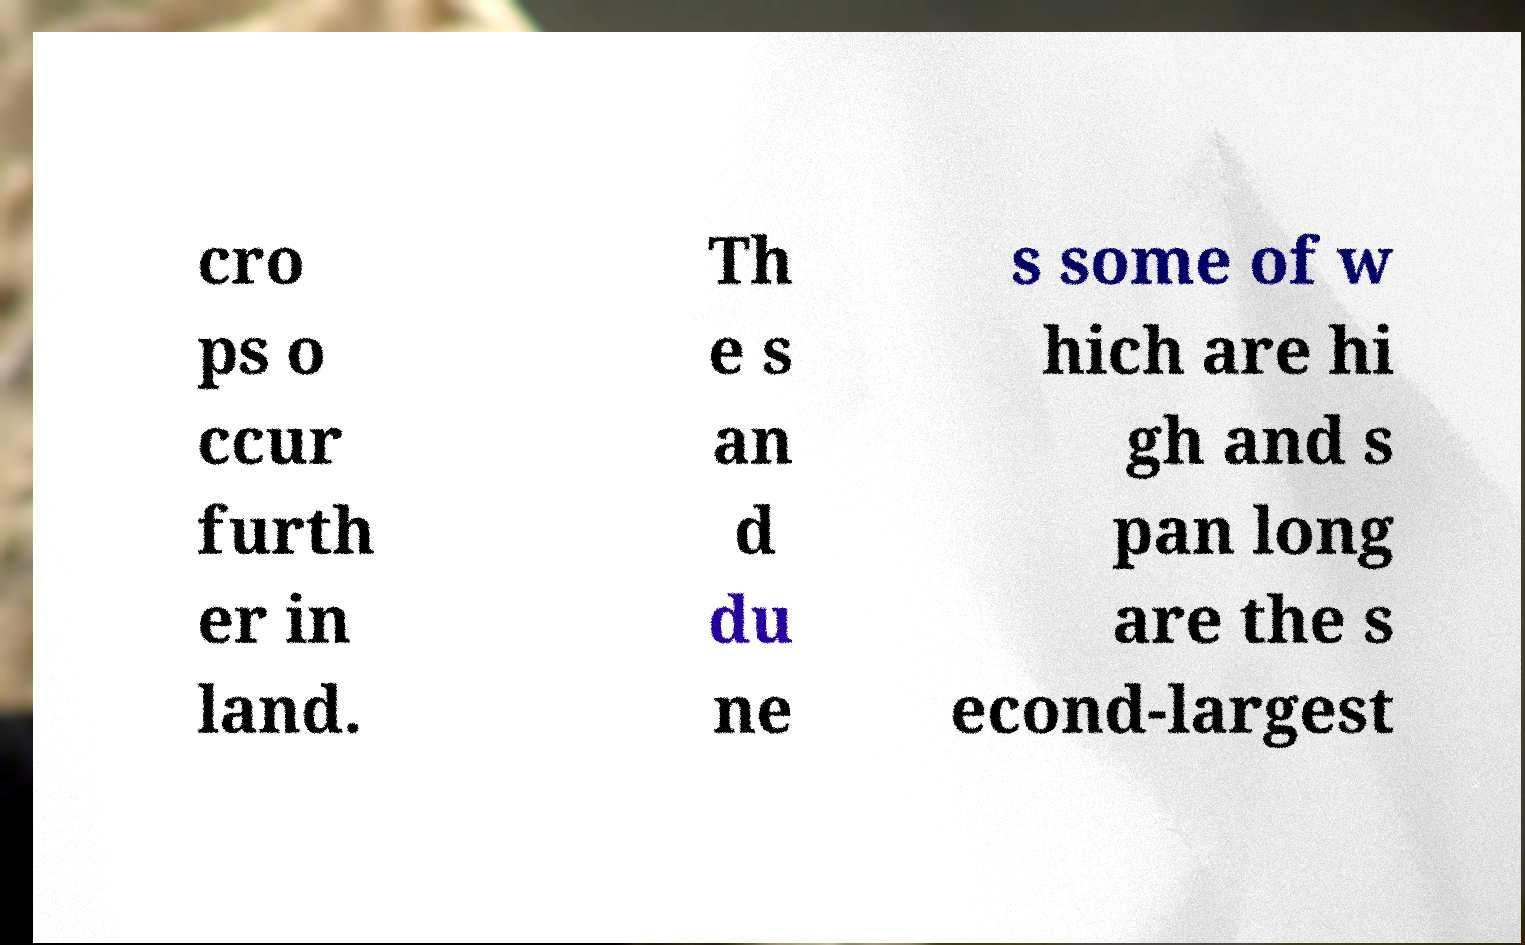For documentation purposes, I need the text within this image transcribed. Could you provide that? cro ps o ccur furth er in land. Th e s an d du ne s some of w hich are hi gh and s pan long are the s econd-largest 